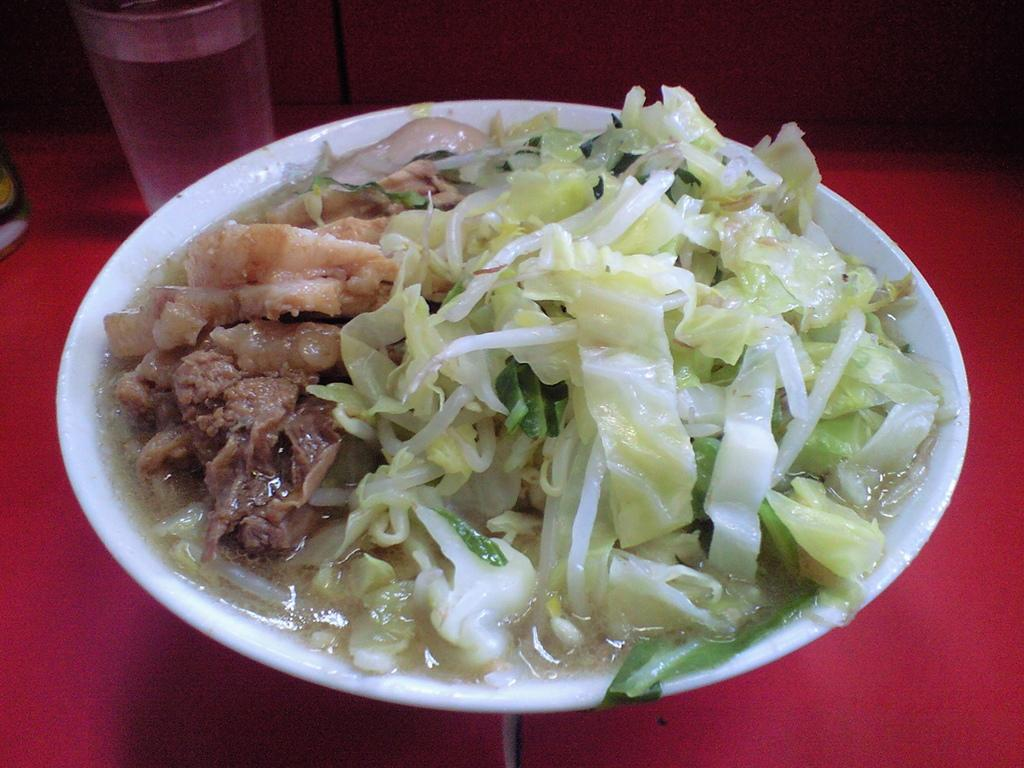What is in the bowl that is visible in the image? There is food in a bowl in the image. What else can be seen on the table in the image? There is a glass with liquid on the table in the image. How many lizards can be seen crawling on the table in the image? There are no lizards present in the image. What type of spark can be seen coming from the glass in the image? There is no spark visible in the image; it is a glass with liquid. 